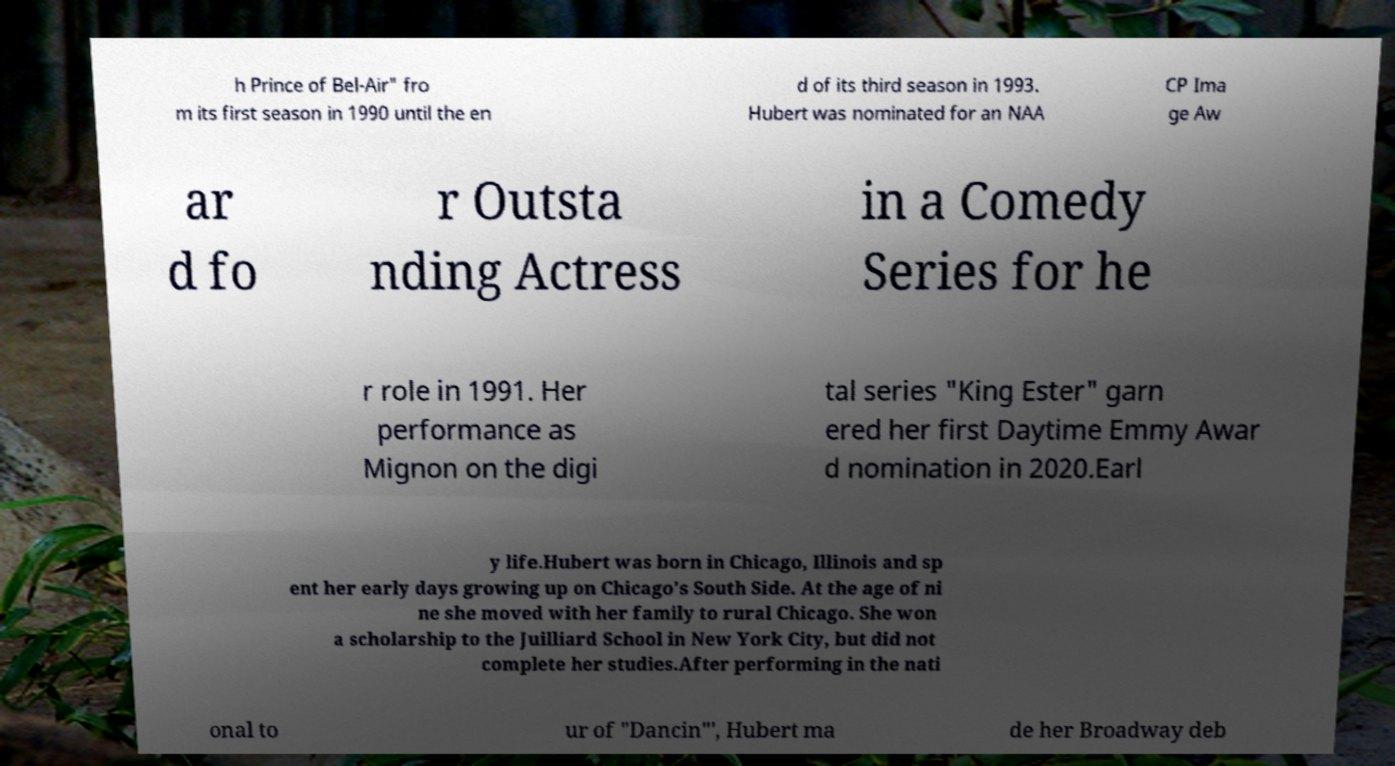Please read and relay the text visible in this image. What does it say? h Prince of Bel-Air" fro m its first season in 1990 until the en d of its third season in 1993. Hubert was nominated for an NAA CP Ima ge Aw ar d fo r Outsta nding Actress in a Comedy Series for he r role in 1991. Her performance as Mignon on the digi tal series "King Ester" garn ered her first Daytime Emmy Awar d nomination in 2020.Earl y life.Hubert was born in Chicago, Illinois and sp ent her early days growing up on Chicago's South Side. At the age of ni ne she moved with her family to rural Chicago. She won a scholarship to the Juilliard School in New York City, but did not complete her studies.After performing in the nati onal to ur of "Dancin"', Hubert ma de her Broadway deb 